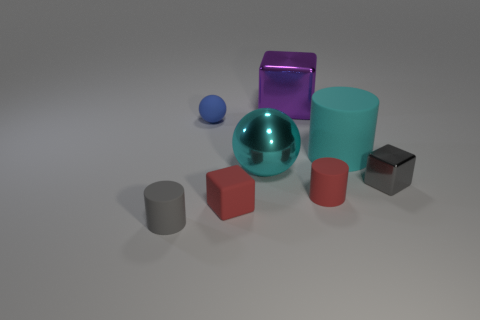Subtract all big purple shiny cubes. How many cubes are left? 2 Subtract 1 blocks. How many blocks are left? 2 Subtract all green blocks. How many red cylinders are left? 1 Subtract all tiny spheres. Subtract all red cylinders. How many objects are left? 6 Add 6 tiny red cylinders. How many tiny red cylinders are left? 7 Add 6 small blocks. How many small blocks exist? 8 Add 2 large things. How many objects exist? 10 Subtract all gray cylinders. How many cylinders are left? 2 Subtract 1 blue spheres. How many objects are left? 7 Subtract all balls. How many objects are left? 6 